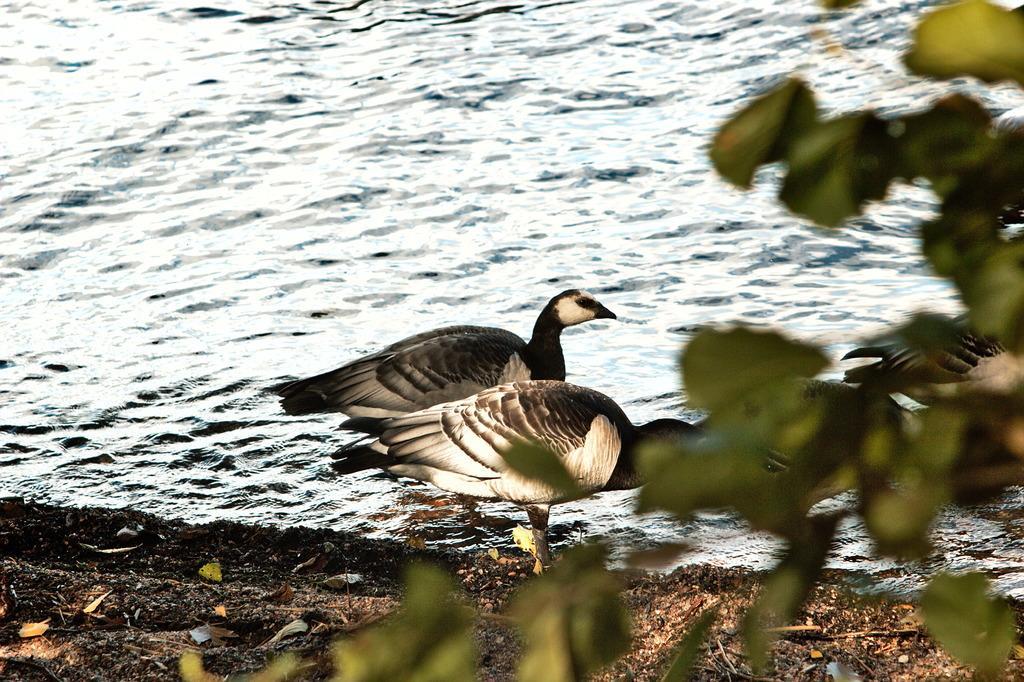In one or two sentences, can you explain what this image depicts? In the center of the image there are two birds in the river. On the left side of the image there is a tree. In the background there is a water. 